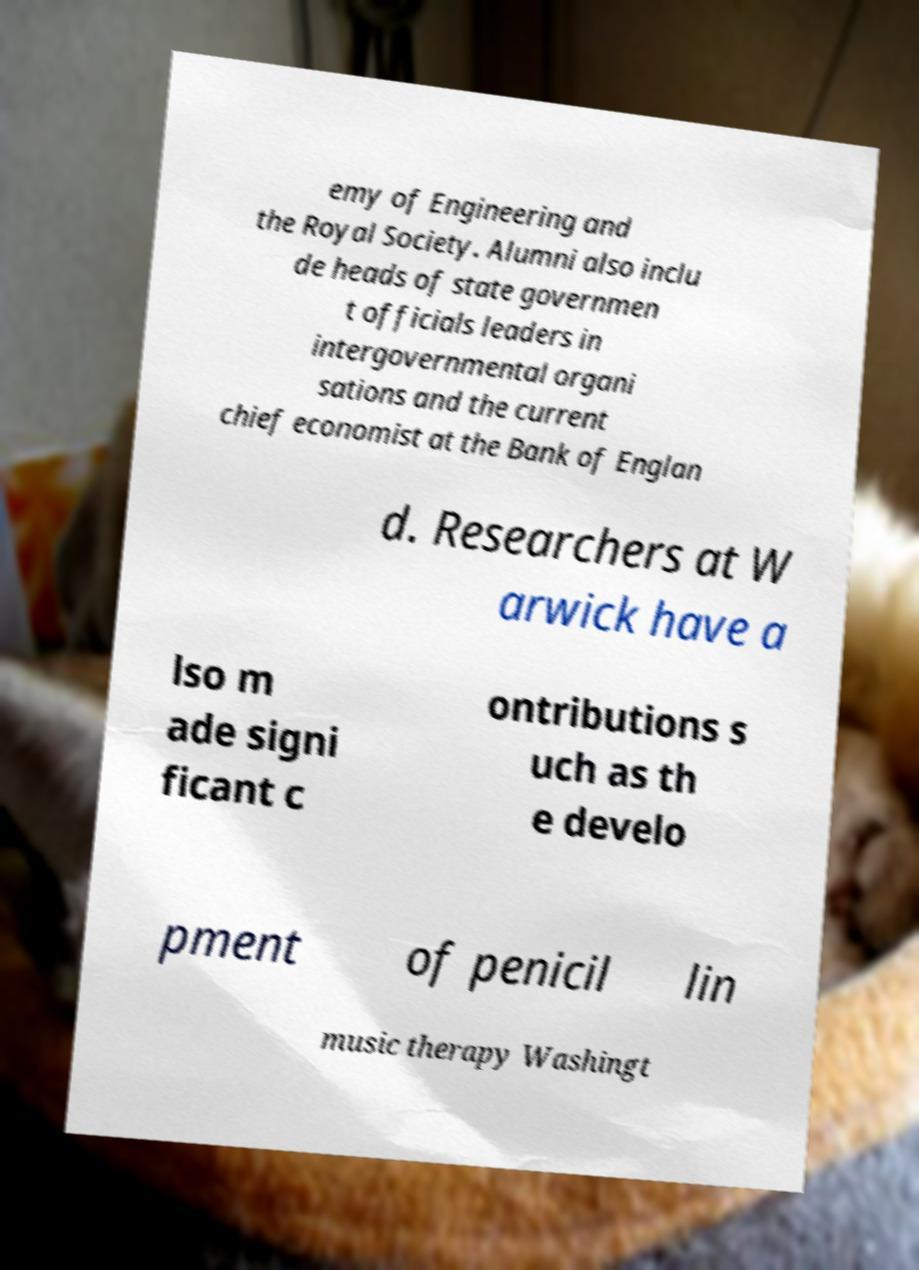Could you assist in decoding the text presented in this image and type it out clearly? emy of Engineering and the Royal Society. Alumni also inclu de heads of state governmen t officials leaders in intergovernmental organi sations and the current chief economist at the Bank of Englan d. Researchers at W arwick have a lso m ade signi ficant c ontributions s uch as th e develo pment of penicil lin music therapy Washingt 